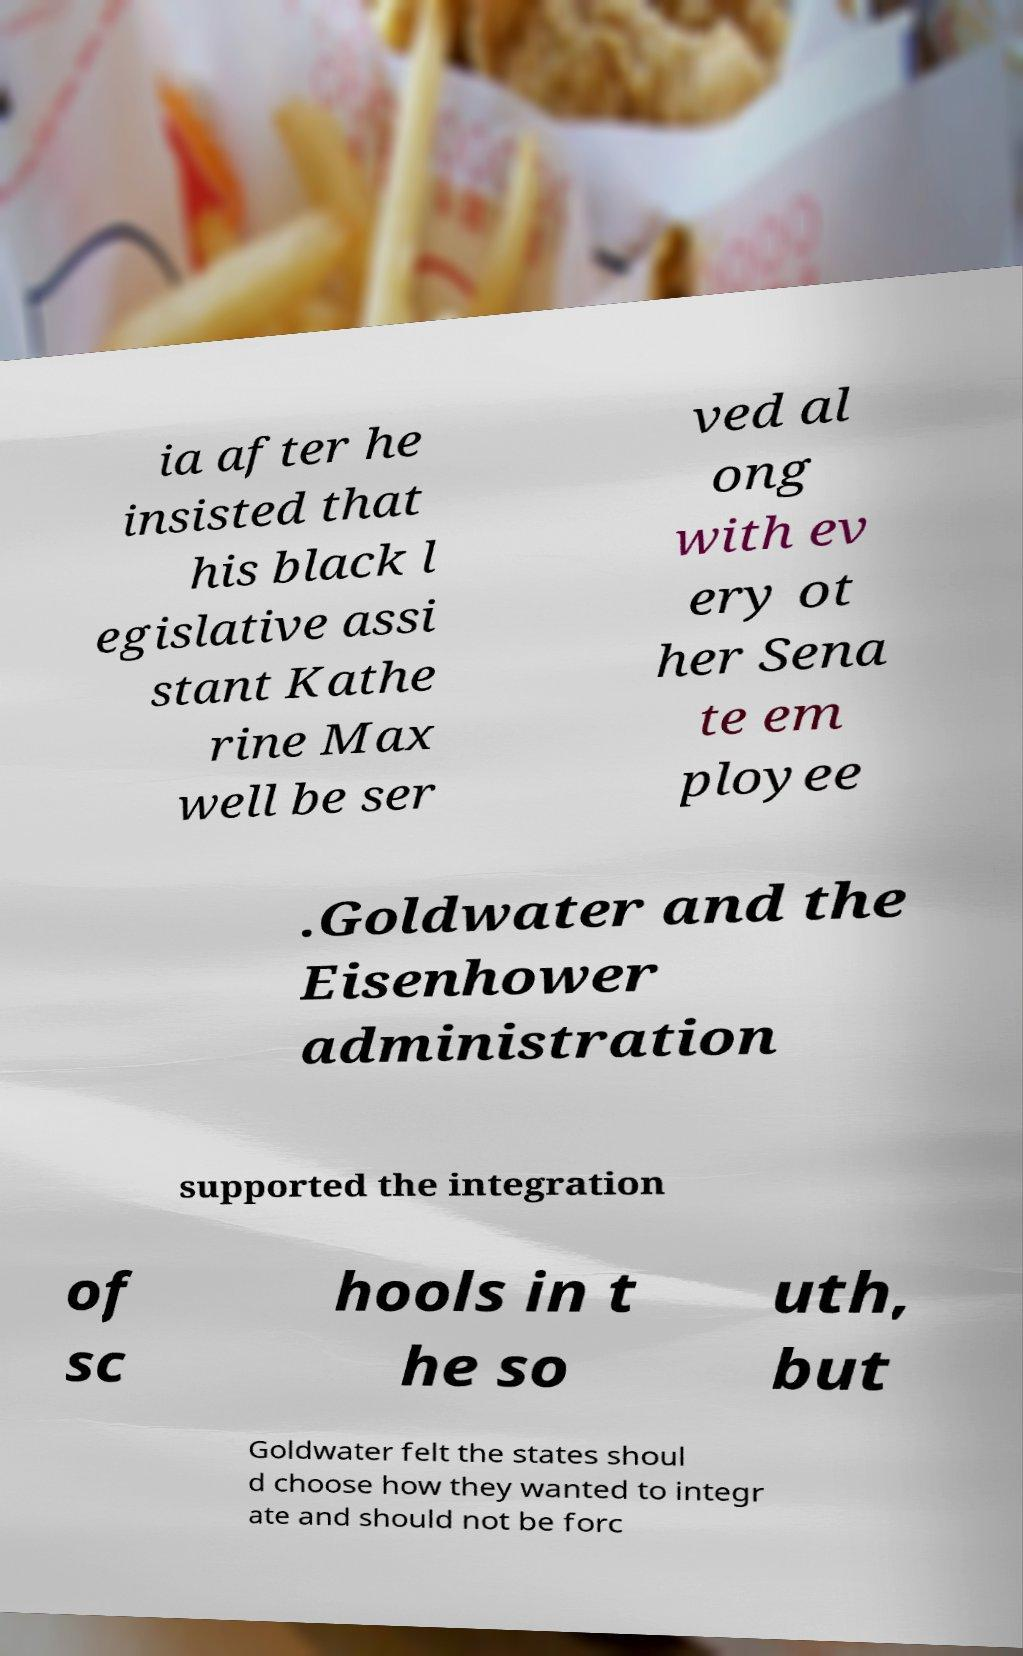I need the written content from this picture converted into text. Can you do that? ia after he insisted that his black l egislative assi stant Kathe rine Max well be ser ved al ong with ev ery ot her Sena te em ployee .Goldwater and the Eisenhower administration supported the integration of sc hools in t he so uth, but Goldwater felt the states shoul d choose how they wanted to integr ate and should not be forc 